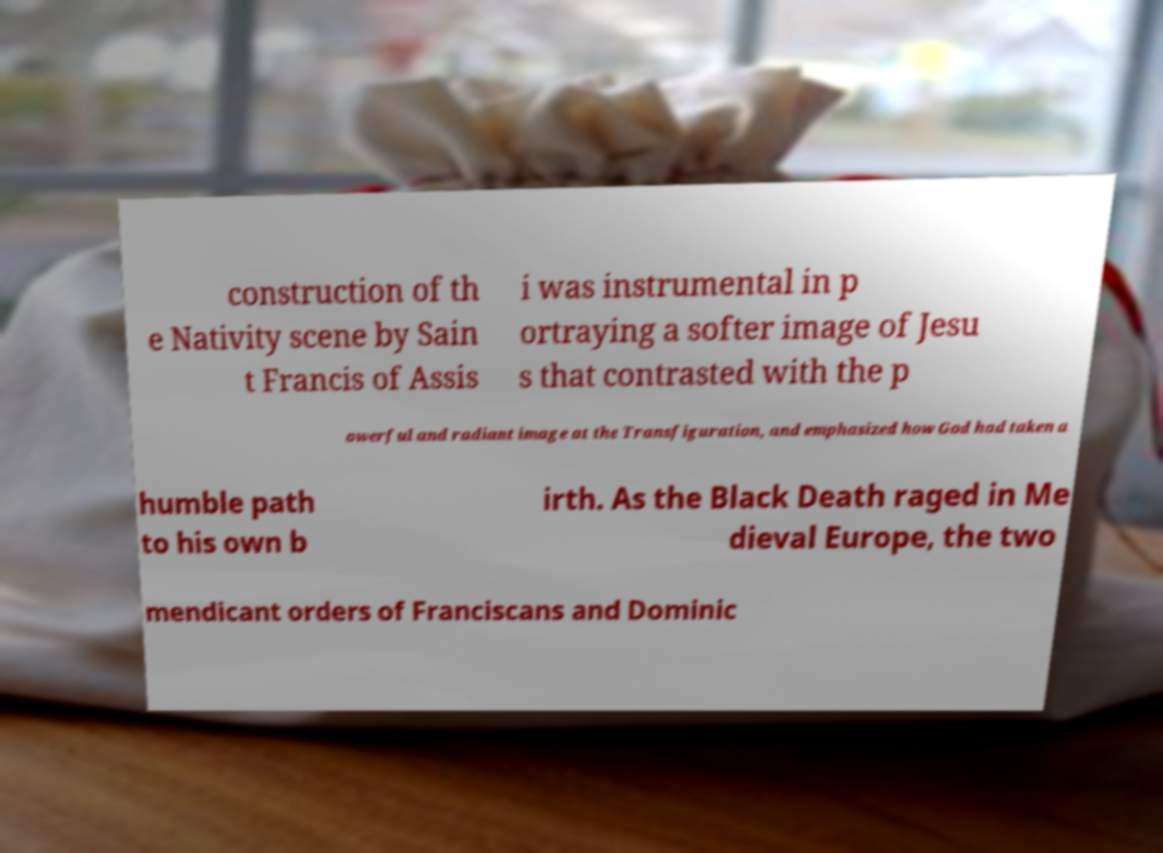I need the written content from this picture converted into text. Can you do that? construction of th e Nativity scene by Sain t Francis of Assis i was instrumental in p ortraying a softer image of Jesu s that contrasted with the p owerful and radiant image at the Transfiguration, and emphasized how God had taken a humble path to his own b irth. As the Black Death raged in Me dieval Europe, the two mendicant orders of Franciscans and Dominic 